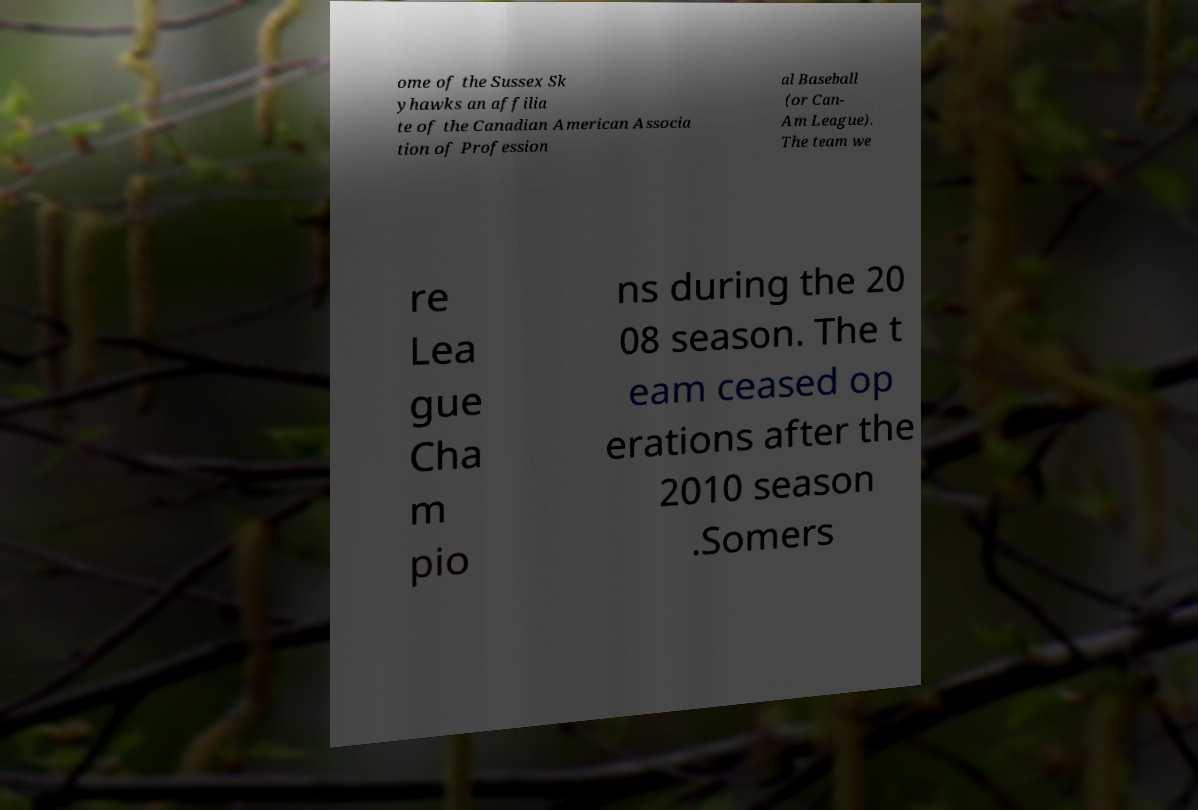For documentation purposes, I need the text within this image transcribed. Could you provide that? ome of the Sussex Sk yhawks an affilia te of the Canadian American Associa tion of Profession al Baseball (or Can- Am League). The team we re Lea gue Cha m pio ns during the 20 08 season. The t eam ceased op erations after the 2010 season .Somers 